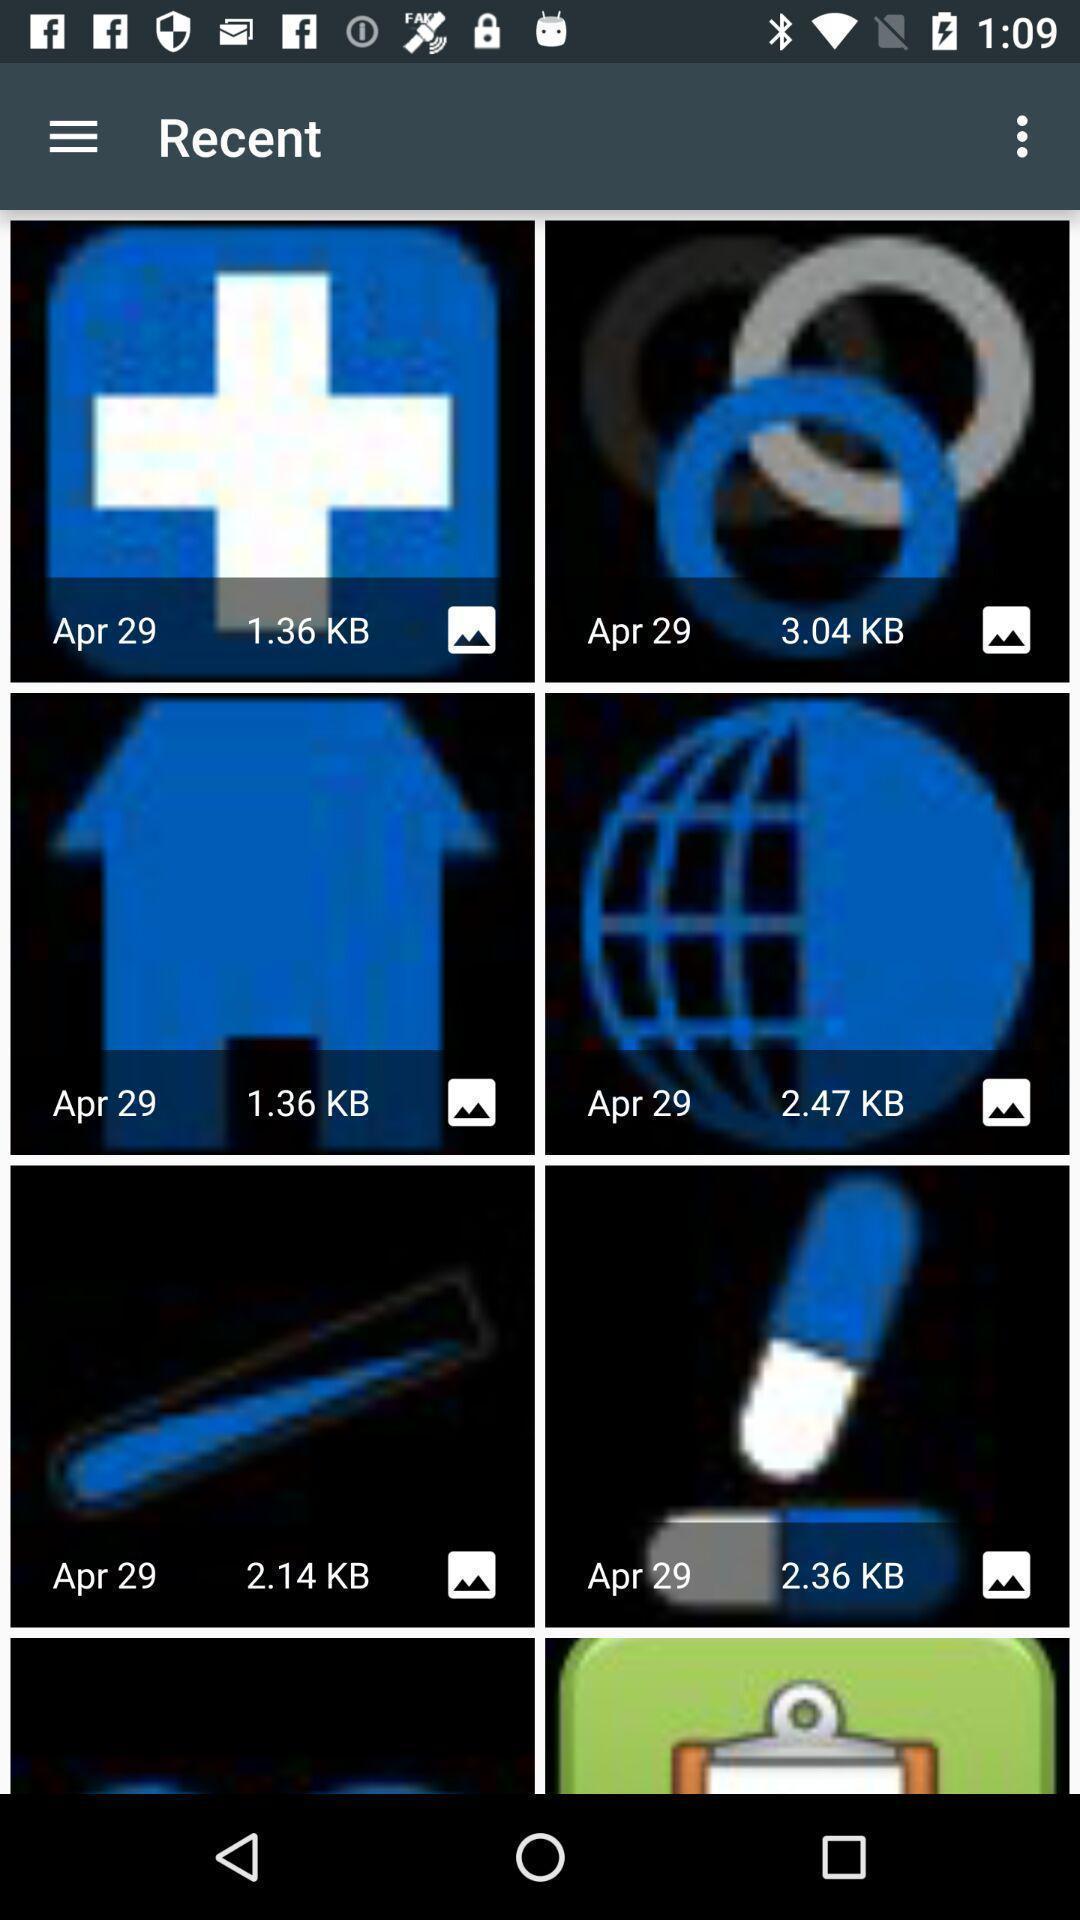Tell me about the visual elements in this screen capture. Screen displaying multiple images in a gallery. 